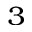Convert formula to latex. <formula><loc_0><loc_0><loc_500><loc_500>^ { 3 }</formula> 